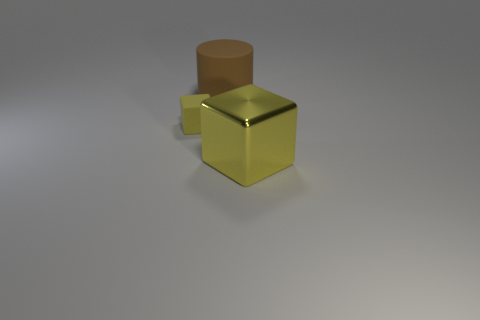Add 3 big matte cylinders. How many objects exist? 6 Subtract all blocks. How many objects are left? 1 Subtract 0 green cylinders. How many objects are left? 3 Subtract all tiny cubes. Subtract all things. How many objects are left? 1 Add 3 large objects. How many large objects are left? 5 Add 1 large purple matte cubes. How many large purple matte cubes exist? 1 